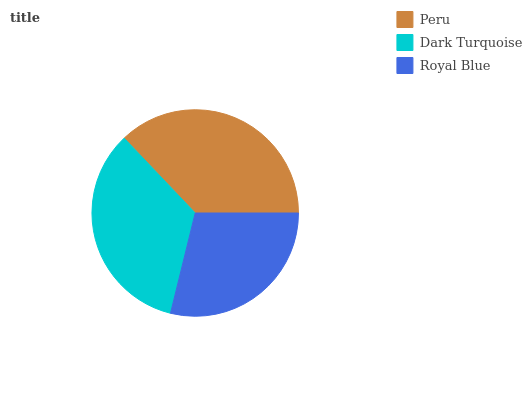Is Royal Blue the minimum?
Answer yes or no. Yes. Is Peru the maximum?
Answer yes or no. Yes. Is Dark Turquoise the minimum?
Answer yes or no. No. Is Dark Turquoise the maximum?
Answer yes or no. No. Is Peru greater than Dark Turquoise?
Answer yes or no. Yes. Is Dark Turquoise less than Peru?
Answer yes or no. Yes. Is Dark Turquoise greater than Peru?
Answer yes or no. No. Is Peru less than Dark Turquoise?
Answer yes or no. No. Is Dark Turquoise the high median?
Answer yes or no. Yes. Is Dark Turquoise the low median?
Answer yes or no. Yes. Is Peru the high median?
Answer yes or no. No. Is Royal Blue the low median?
Answer yes or no. No. 